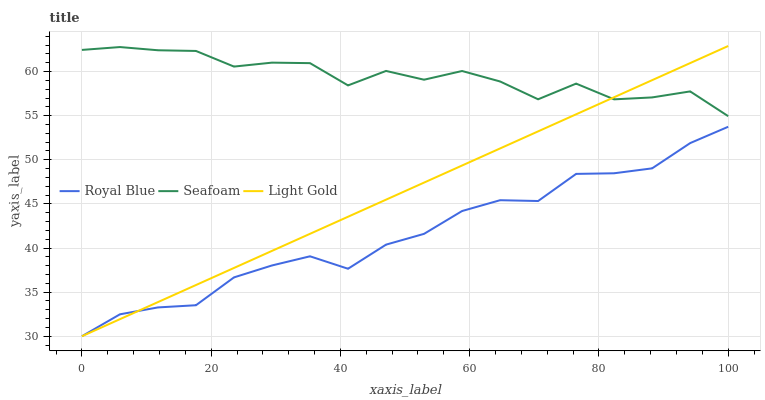Does Light Gold have the minimum area under the curve?
Answer yes or no. No. Does Light Gold have the maximum area under the curve?
Answer yes or no. No. Is Seafoam the smoothest?
Answer yes or no. No. Is Light Gold the roughest?
Answer yes or no. No. Does Seafoam have the lowest value?
Answer yes or no. No. Does Seafoam have the highest value?
Answer yes or no. No. Is Royal Blue less than Seafoam?
Answer yes or no. Yes. Is Seafoam greater than Royal Blue?
Answer yes or no. Yes. Does Royal Blue intersect Seafoam?
Answer yes or no. No. 